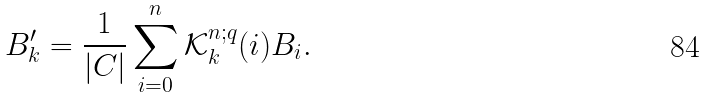<formula> <loc_0><loc_0><loc_500><loc_500>B ^ { \prime } _ { k } = \frac { 1 } { | C | } \sum _ { i = 0 } ^ { n } \mathcal { K } _ { k } ^ { n ; q } ( i ) B _ { i } .</formula> 